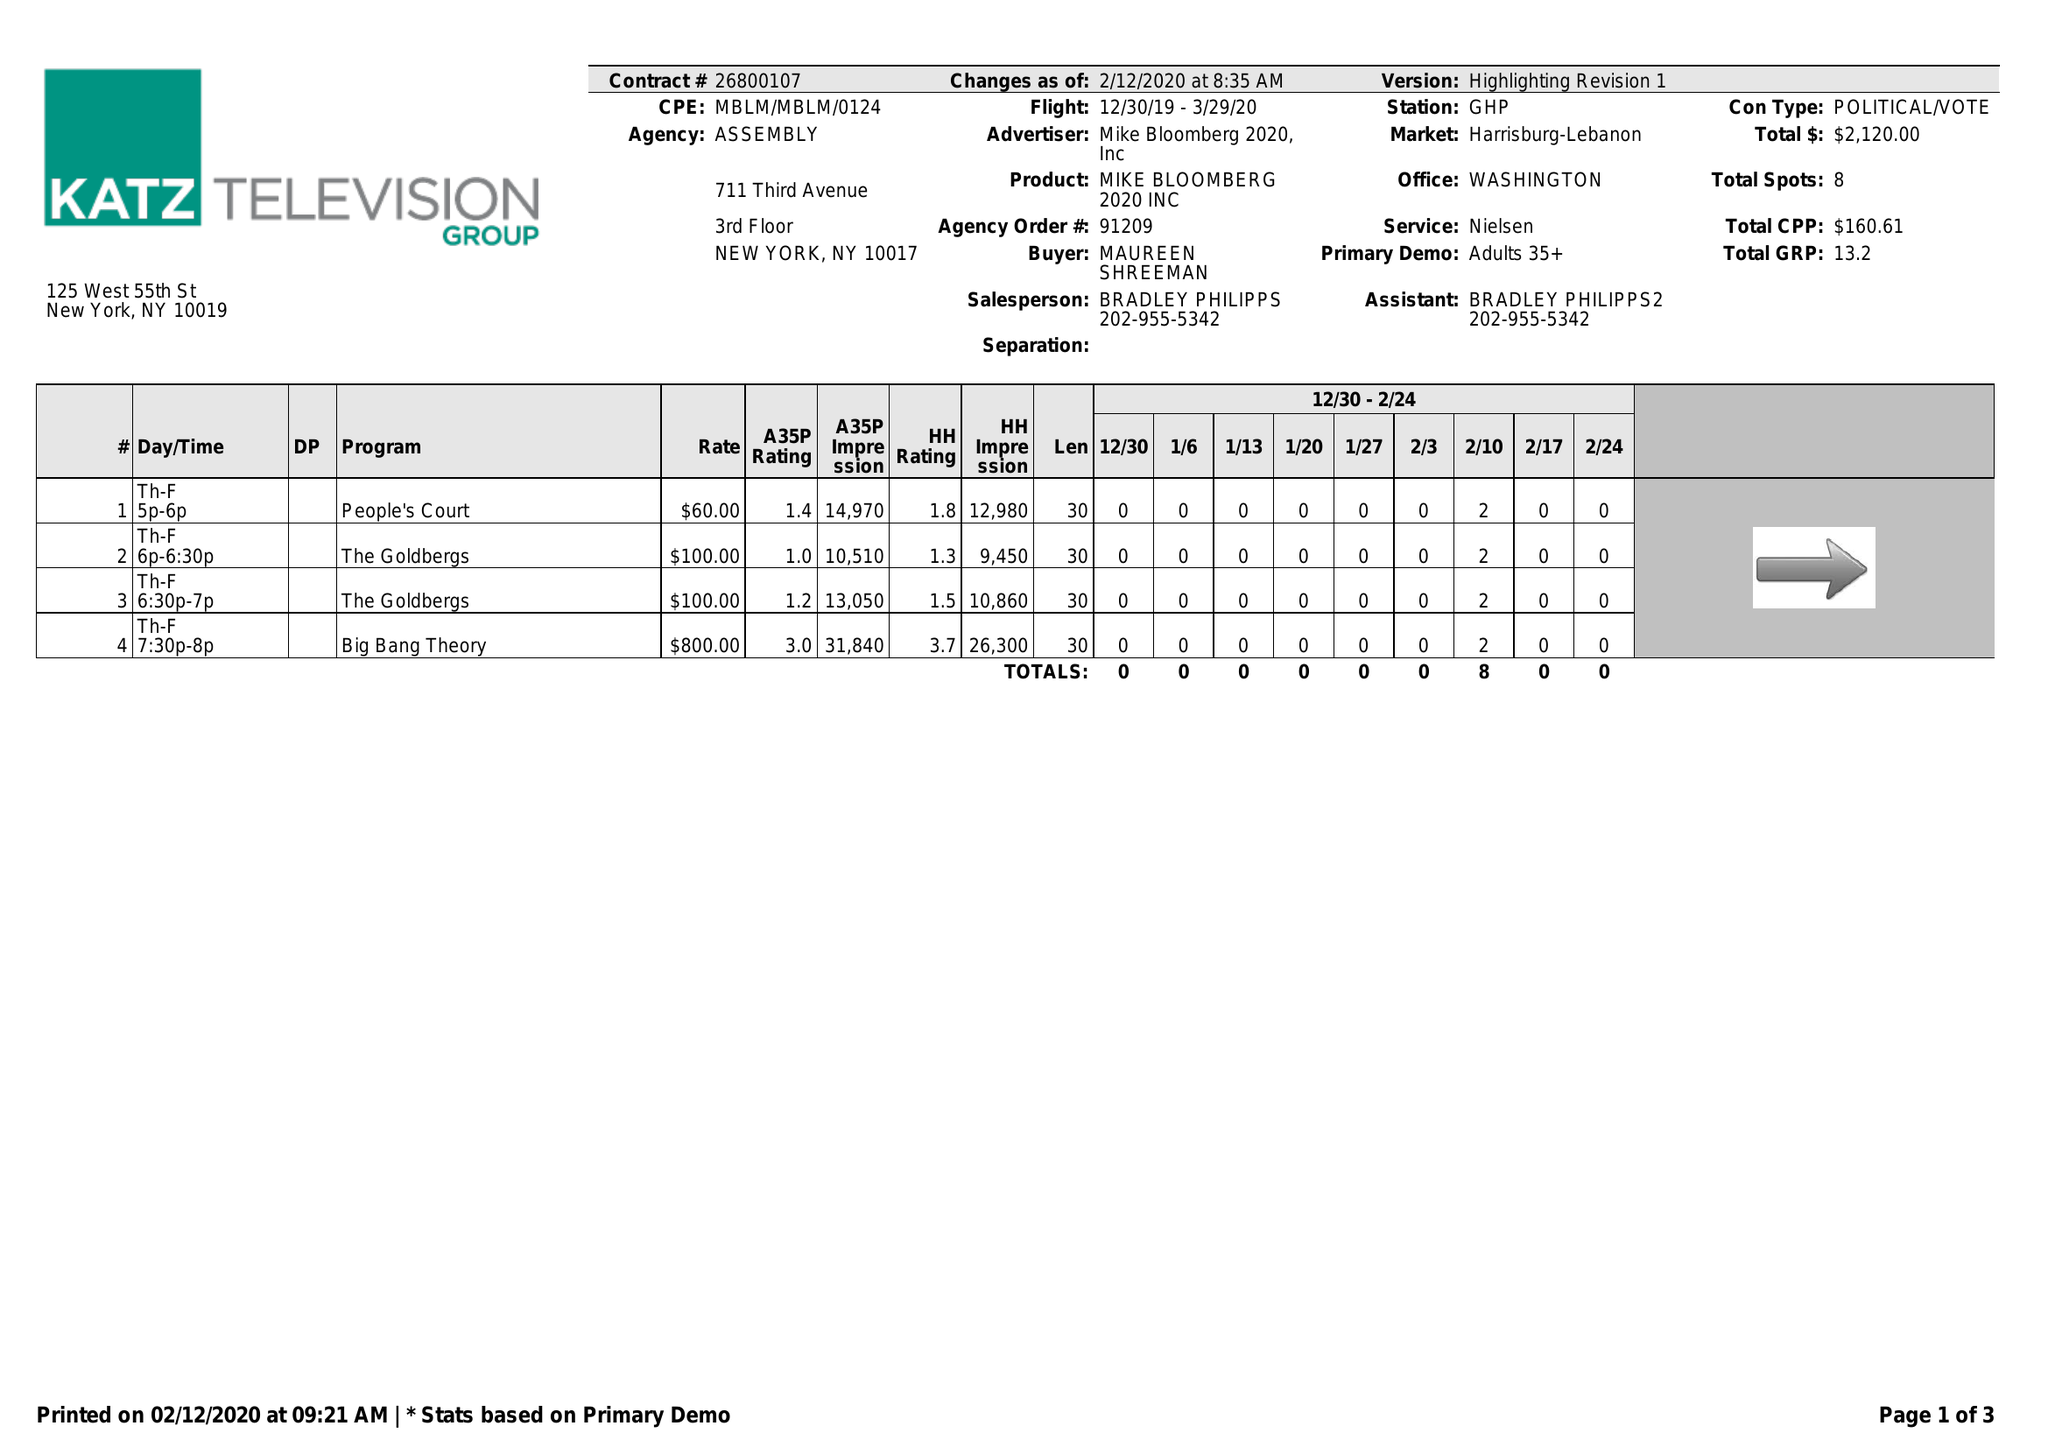What is the value for the gross_amount?
Answer the question using a single word or phrase. 2120.00 